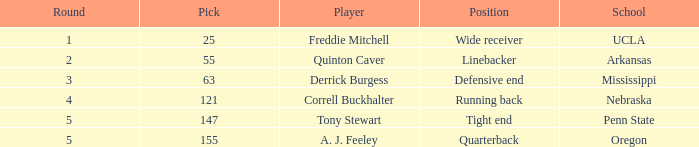What was a.j. feeley's occupation when he got drafted in the fifth round? Quarterback. 